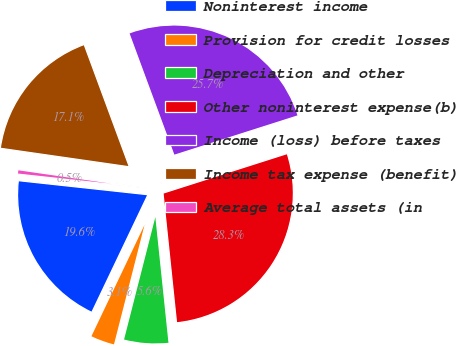Convert chart to OTSL. <chart><loc_0><loc_0><loc_500><loc_500><pie_chart><fcel>Noninterest income<fcel>Provision for credit losses<fcel>Depreciation and other<fcel>Other noninterest expense(b)<fcel>Income (loss) before taxes<fcel>Income tax expense (benefit)<fcel>Average total assets (in<nl><fcel>19.64%<fcel>3.1%<fcel>5.64%<fcel>28.26%<fcel>25.72%<fcel>17.1%<fcel>0.55%<nl></chart> 